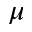<formula> <loc_0><loc_0><loc_500><loc_500>\mu</formula> 